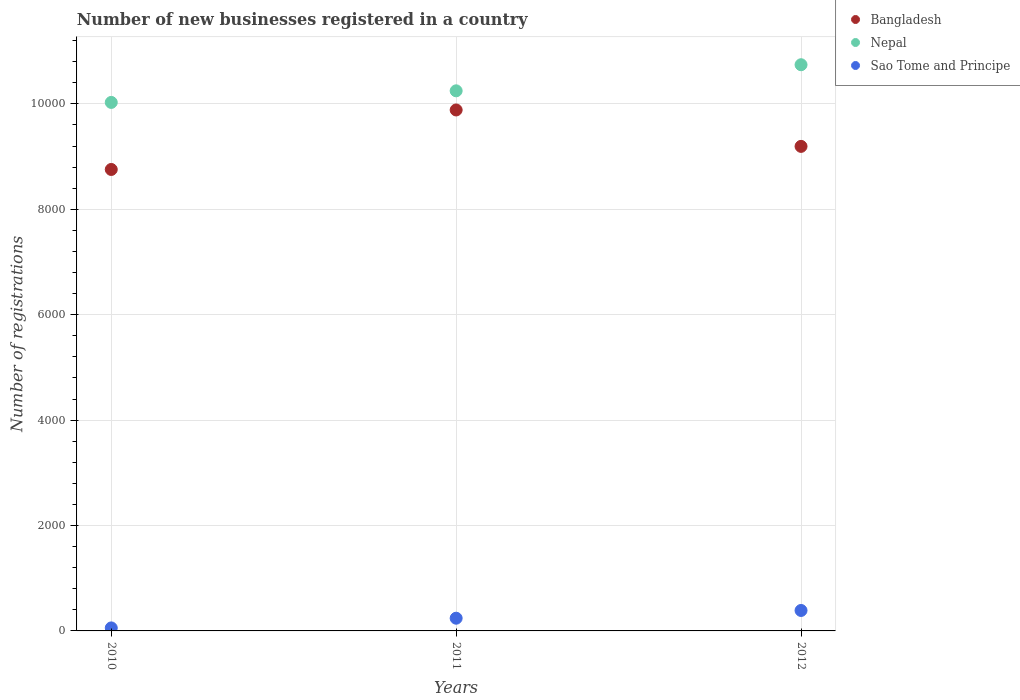How many different coloured dotlines are there?
Your answer should be very brief. 3. What is the number of new businesses registered in Bangladesh in 2010?
Your response must be concise. 8755. Across all years, what is the maximum number of new businesses registered in Sao Tome and Principe?
Your response must be concise. 388. Across all years, what is the minimum number of new businesses registered in Sao Tome and Principe?
Provide a succinct answer. 57. In which year was the number of new businesses registered in Sao Tome and Principe maximum?
Your response must be concise. 2012. In which year was the number of new businesses registered in Bangladesh minimum?
Your answer should be compact. 2010. What is the total number of new businesses registered in Bangladesh in the graph?
Provide a short and direct response. 2.78e+04. What is the difference between the number of new businesses registered in Sao Tome and Principe in 2010 and that in 2012?
Ensure brevity in your answer.  -331. What is the difference between the number of new businesses registered in Bangladesh in 2011 and the number of new businesses registered in Sao Tome and Principe in 2012?
Ensure brevity in your answer.  9496. What is the average number of new businesses registered in Nepal per year?
Provide a short and direct response. 1.03e+04. In the year 2010, what is the difference between the number of new businesses registered in Sao Tome and Principe and number of new businesses registered in Bangladesh?
Provide a short and direct response. -8698. In how many years, is the number of new businesses registered in Nepal greater than 6800?
Your answer should be very brief. 3. What is the ratio of the number of new businesses registered in Bangladesh in 2010 to that in 2011?
Give a very brief answer. 0.89. Is the difference between the number of new businesses registered in Sao Tome and Principe in 2011 and 2012 greater than the difference between the number of new businesses registered in Bangladesh in 2011 and 2012?
Offer a very short reply. No. What is the difference between the highest and the second highest number of new businesses registered in Bangladesh?
Ensure brevity in your answer.  691. What is the difference between the highest and the lowest number of new businesses registered in Sao Tome and Principe?
Provide a short and direct response. 331. In how many years, is the number of new businesses registered in Nepal greater than the average number of new businesses registered in Nepal taken over all years?
Keep it short and to the point. 1. Is the sum of the number of new businesses registered in Nepal in 2011 and 2012 greater than the maximum number of new businesses registered in Sao Tome and Principe across all years?
Provide a succinct answer. Yes. Does the number of new businesses registered in Nepal monotonically increase over the years?
Ensure brevity in your answer.  Yes. Is the number of new businesses registered in Nepal strictly less than the number of new businesses registered in Sao Tome and Principe over the years?
Ensure brevity in your answer.  No. What is the difference between two consecutive major ticks on the Y-axis?
Provide a succinct answer. 2000. Does the graph contain any zero values?
Make the answer very short. No. Does the graph contain grids?
Give a very brief answer. Yes. How many legend labels are there?
Your answer should be very brief. 3. What is the title of the graph?
Offer a very short reply. Number of new businesses registered in a country. What is the label or title of the Y-axis?
Ensure brevity in your answer.  Number of registrations. What is the Number of registrations of Bangladesh in 2010?
Your response must be concise. 8755. What is the Number of registrations of Nepal in 2010?
Your answer should be very brief. 1.00e+04. What is the Number of registrations in Bangladesh in 2011?
Offer a very short reply. 9884. What is the Number of registrations in Nepal in 2011?
Give a very brief answer. 1.02e+04. What is the Number of registrations in Sao Tome and Principe in 2011?
Your answer should be very brief. 241. What is the Number of registrations of Bangladesh in 2012?
Make the answer very short. 9193. What is the Number of registrations in Nepal in 2012?
Keep it short and to the point. 1.07e+04. What is the Number of registrations in Sao Tome and Principe in 2012?
Offer a very short reply. 388. Across all years, what is the maximum Number of registrations of Bangladesh?
Keep it short and to the point. 9884. Across all years, what is the maximum Number of registrations of Nepal?
Give a very brief answer. 1.07e+04. Across all years, what is the maximum Number of registrations of Sao Tome and Principe?
Your answer should be very brief. 388. Across all years, what is the minimum Number of registrations of Bangladesh?
Offer a very short reply. 8755. Across all years, what is the minimum Number of registrations in Nepal?
Offer a terse response. 1.00e+04. Across all years, what is the minimum Number of registrations of Sao Tome and Principe?
Give a very brief answer. 57. What is the total Number of registrations of Bangladesh in the graph?
Give a very brief answer. 2.78e+04. What is the total Number of registrations in Nepal in the graph?
Provide a succinct answer. 3.10e+04. What is the total Number of registrations in Sao Tome and Principe in the graph?
Provide a short and direct response. 686. What is the difference between the Number of registrations in Bangladesh in 2010 and that in 2011?
Keep it short and to the point. -1129. What is the difference between the Number of registrations of Nepal in 2010 and that in 2011?
Give a very brief answer. -220. What is the difference between the Number of registrations of Sao Tome and Principe in 2010 and that in 2011?
Your response must be concise. -184. What is the difference between the Number of registrations of Bangladesh in 2010 and that in 2012?
Ensure brevity in your answer.  -438. What is the difference between the Number of registrations of Nepal in 2010 and that in 2012?
Your response must be concise. -715. What is the difference between the Number of registrations in Sao Tome and Principe in 2010 and that in 2012?
Offer a terse response. -331. What is the difference between the Number of registrations in Bangladesh in 2011 and that in 2012?
Ensure brevity in your answer.  691. What is the difference between the Number of registrations of Nepal in 2011 and that in 2012?
Offer a terse response. -495. What is the difference between the Number of registrations of Sao Tome and Principe in 2011 and that in 2012?
Ensure brevity in your answer.  -147. What is the difference between the Number of registrations of Bangladesh in 2010 and the Number of registrations of Nepal in 2011?
Keep it short and to the point. -1492. What is the difference between the Number of registrations of Bangladesh in 2010 and the Number of registrations of Sao Tome and Principe in 2011?
Give a very brief answer. 8514. What is the difference between the Number of registrations of Nepal in 2010 and the Number of registrations of Sao Tome and Principe in 2011?
Give a very brief answer. 9786. What is the difference between the Number of registrations in Bangladesh in 2010 and the Number of registrations in Nepal in 2012?
Your response must be concise. -1987. What is the difference between the Number of registrations of Bangladesh in 2010 and the Number of registrations of Sao Tome and Principe in 2012?
Offer a very short reply. 8367. What is the difference between the Number of registrations in Nepal in 2010 and the Number of registrations in Sao Tome and Principe in 2012?
Make the answer very short. 9639. What is the difference between the Number of registrations of Bangladesh in 2011 and the Number of registrations of Nepal in 2012?
Keep it short and to the point. -858. What is the difference between the Number of registrations in Bangladesh in 2011 and the Number of registrations in Sao Tome and Principe in 2012?
Ensure brevity in your answer.  9496. What is the difference between the Number of registrations in Nepal in 2011 and the Number of registrations in Sao Tome and Principe in 2012?
Offer a terse response. 9859. What is the average Number of registrations of Bangladesh per year?
Your response must be concise. 9277.33. What is the average Number of registrations in Nepal per year?
Provide a succinct answer. 1.03e+04. What is the average Number of registrations in Sao Tome and Principe per year?
Your response must be concise. 228.67. In the year 2010, what is the difference between the Number of registrations in Bangladesh and Number of registrations in Nepal?
Give a very brief answer. -1272. In the year 2010, what is the difference between the Number of registrations of Bangladesh and Number of registrations of Sao Tome and Principe?
Provide a short and direct response. 8698. In the year 2010, what is the difference between the Number of registrations of Nepal and Number of registrations of Sao Tome and Principe?
Your answer should be very brief. 9970. In the year 2011, what is the difference between the Number of registrations in Bangladesh and Number of registrations in Nepal?
Ensure brevity in your answer.  -363. In the year 2011, what is the difference between the Number of registrations in Bangladesh and Number of registrations in Sao Tome and Principe?
Give a very brief answer. 9643. In the year 2011, what is the difference between the Number of registrations in Nepal and Number of registrations in Sao Tome and Principe?
Offer a very short reply. 1.00e+04. In the year 2012, what is the difference between the Number of registrations in Bangladesh and Number of registrations in Nepal?
Your response must be concise. -1549. In the year 2012, what is the difference between the Number of registrations of Bangladesh and Number of registrations of Sao Tome and Principe?
Offer a terse response. 8805. In the year 2012, what is the difference between the Number of registrations in Nepal and Number of registrations in Sao Tome and Principe?
Give a very brief answer. 1.04e+04. What is the ratio of the Number of registrations of Bangladesh in 2010 to that in 2011?
Offer a terse response. 0.89. What is the ratio of the Number of registrations of Nepal in 2010 to that in 2011?
Provide a succinct answer. 0.98. What is the ratio of the Number of registrations of Sao Tome and Principe in 2010 to that in 2011?
Your answer should be compact. 0.24. What is the ratio of the Number of registrations in Bangladesh in 2010 to that in 2012?
Your answer should be compact. 0.95. What is the ratio of the Number of registrations in Nepal in 2010 to that in 2012?
Offer a terse response. 0.93. What is the ratio of the Number of registrations in Sao Tome and Principe in 2010 to that in 2012?
Provide a short and direct response. 0.15. What is the ratio of the Number of registrations in Bangladesh in 2011 to that in 2012?
Offer a terse response. 1.08. What is the ratio of the Number of registrations in Nepal in 2011 to that in 2012?
Offer a terse response. 0.95. What is the ratio of the Number of registrations in Sao Tome and Principe in 2011 to that in 2012?
Provide a short and direct response. 0.62. What is the difference between the highest and the second highest Number of registrations of Bangladesh?
Keep it short and to the point. 691. What is the difference between the highest and the second highest Number of registrations of Nepal?
Ensure brevity in your answer.  495. What is the difference between the highest and the second highest Number of registrations of Sao Tome and Principe?
Give a very brief answer. 147. What is the difference between the highest and the lowest Number of registrations of Bangladesh?
Offer a terse response. 1129. What is the difference between the highest and the lowest Number of registrations of Nepal?
Keep it short and to the point. 715. What is the difference between the highest and the lowest Number of registrations in Sao Tome and Principe?
Your response must be concise. 331. 